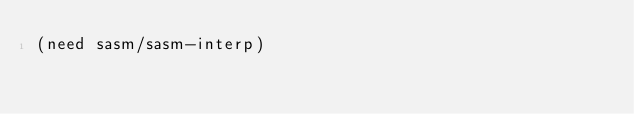Convert code to text. <code><loc_0><loc_0><loc_500><loc_500><_Scheme_>(need sasm/sasm-interp)
</code> 